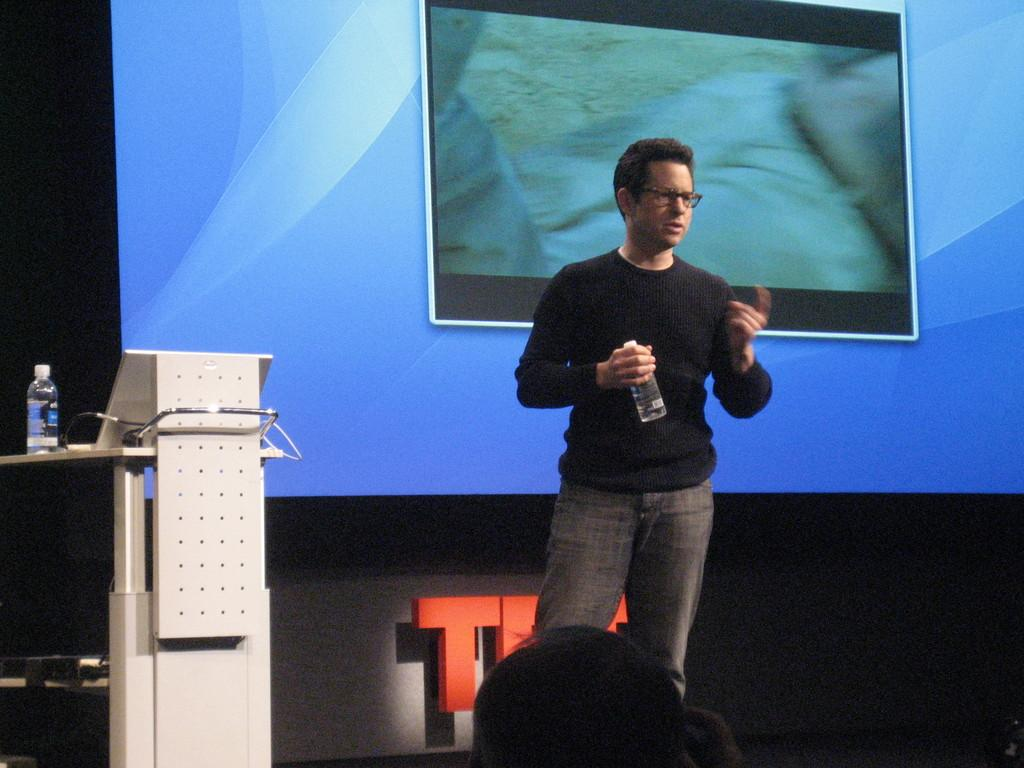What can be seen in the foreground of the picture? There are people in the foreground of the picture. What is located on the left side of the image? There is a podium and a water bottle on the left side of the image. What is in the middle of the image? There is a projector screen and a blackboard in the middle of the image. What is written on the blackboard? There is text visible on the blackboard. How many trees can be seen in the image? There are no trees visible in the image. Are there any dogs present in the image? There are no dogs present in the image. 